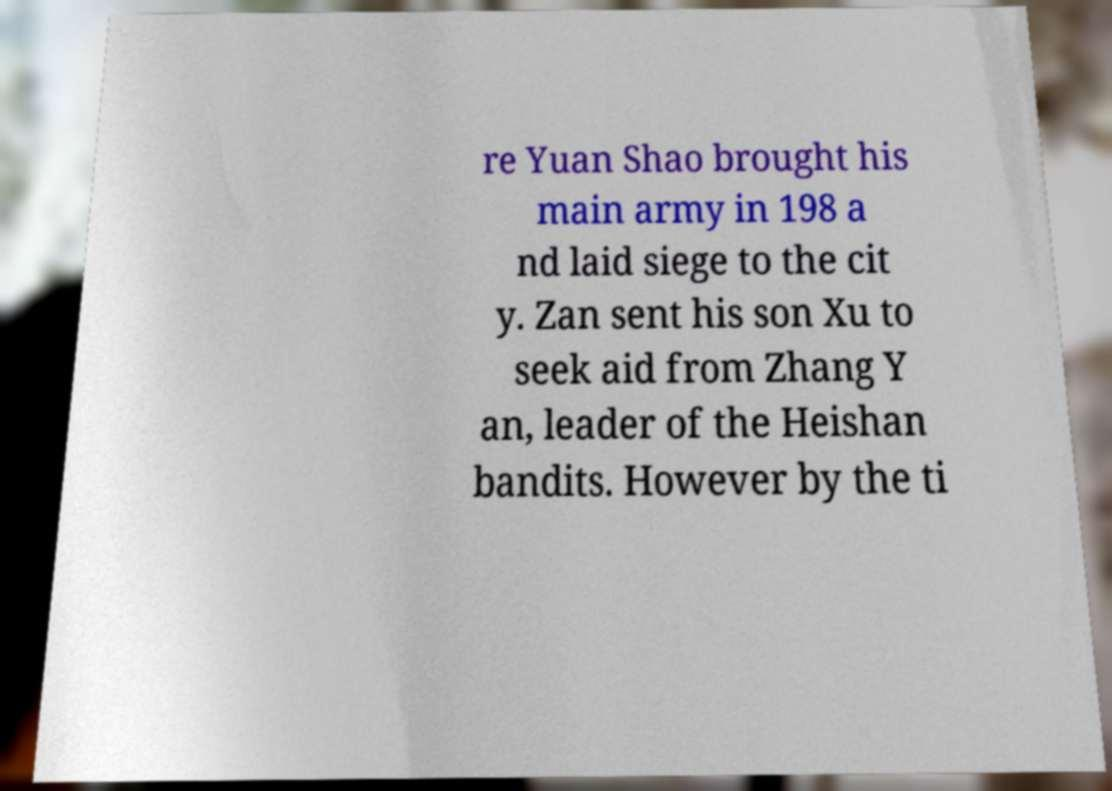What messages or text are displayed in this image? I need them in a readable, typed format. re Yuan Shao brought his main army in 198 a nd laid siege to the cit y. Zan sent his son Xu to seek aid from Zhang Y an, leader of the Heishan bandits. However by the ti 